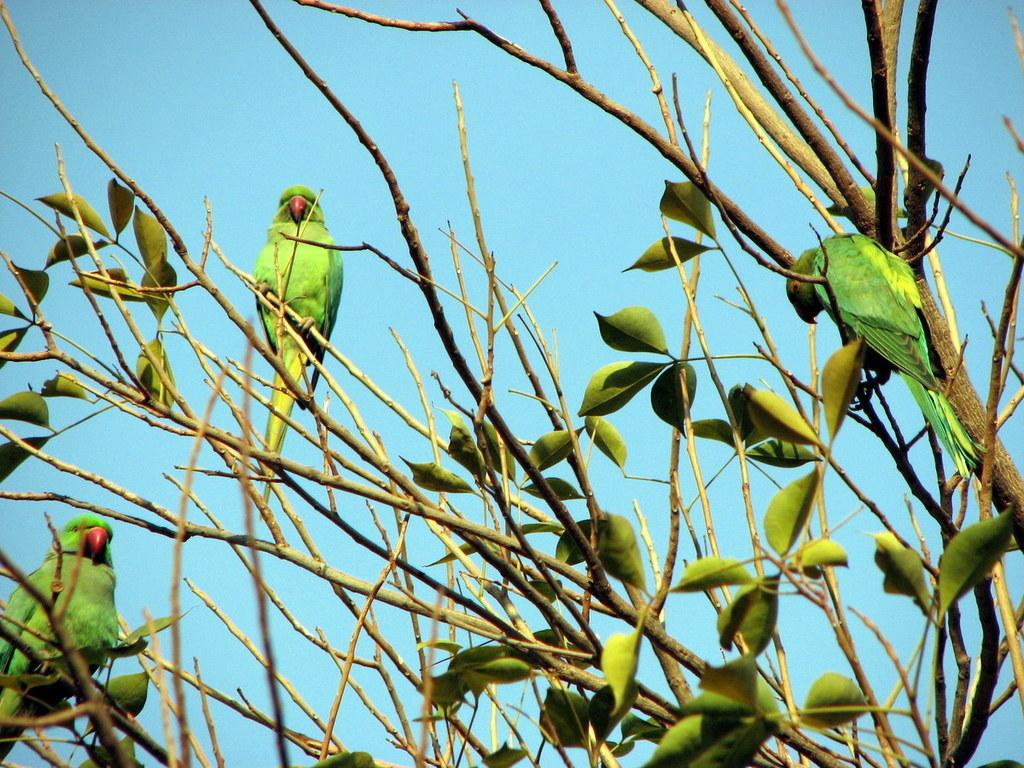How many parrots are in the image? There are three green parrots in the image. What are the parrots standing on? The parrots are standing on branches. What type of vegetation can be seen in the image? There are leaves visible in the image. What is visible in the background of the image? The sky is visible in the image. What type of can is hanging from the parrots' beaks in the image? There are no cans present in the image; the parrots are standing on branches with leaves visible. 